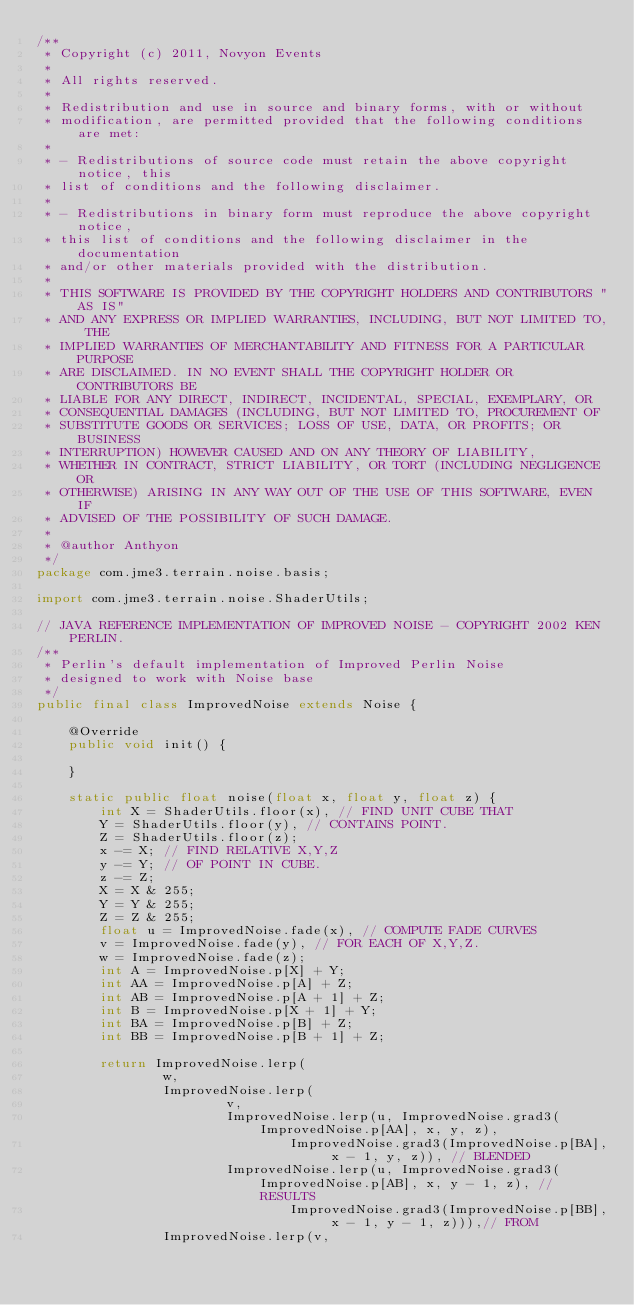Convert code to text. <code><loc_0><loc_0><loc_500><loc_500><_Java_>/**
 * Copyright (c) 2011, Novyon Events
 * 
 * All rights reserved.
 * 
 * Redistribution and use in source and binary forms, with or without
 * modification, are permitted provided that the following conditions are met:
 * 
 * - Redistributions of source code must retain the above copyright notice, this
 * list of conditions and the following disclaimer.
 * 
 * - Redistributions in binary form must reproduce the above copyright notice,
 * this list of conditions and the following disclaimer in the documentation
 * and/or other materials provided with the distribution.
 * 
 * THIS SOFTWARE IS PROVIDED BY THE COPYRIGHT HOLDERS AND CONTRIBUTORS "AS IS"
 * AND ANY EXPRESS OR IMPLIED WARRANTIES, INCLUDING, BUT NOT LIMITED TO, THE
 * IMPLIED WARRANTIES OF MERCHANTABILITY AND FITNESS FOR A PARTICULAR PURPOSE
 * ARE DISCLAIMED. IN NO EVENT SHALL THE COPYRIGHT HOLDER OR CONTRIBUTORS BE
 * LIABLE FOR ANY DIRECT, INDIRECT, INCIDENTAL, SPECIAL, EXEMPLARY, OR
 * CONSEQUENTIAL DAMAGES (INCLUDING, BUT NOT LIMITED TO, PROCUREMENT OF
 * SUBSTITUTE GOODS OR SERVICES; LOSS OF USE, DATA, OR PROFITS; OR BUSINESS
 * INTERRUPTION) HOWEVER CAUSED AND ON ANY THEORY OF LIABILITY,
 * WHETHER IN CONTRACT, STRICT LIABILITY, OR TORT (INCLUDING NEGLIGENCE OR
 * OTHERWISE) ARISING IN ANY WAY OUT OF THE USE OF THIS SOFTWARE, EVEN IF
 * ADVISED OF THE POSSIBILITY OF SUCH DAMAGE.
 * 
 * @author Anthyon
 */
package com.jme3.terrain.noise.basis;

import com.jme3.terrain.noise.ShaderUtils;

// JAVA REFERENCE IMPLEMENTATION OF IMPROVED NOISE - COPYRIGHT 2002 KEN PERLIN.
/**
 * Perlin's default implementation of Improved Perlin Noise
 * designed to work with Noise base
 */
public final class ImprovedNoise extends Noise {

    @Override
    public void init() {

    }

    static public float noise(float x, float y, float z) {
        int X = ShaderUtils.floor(x), // FIND UNIT CUBE THAT
        Y = ShaderUtils.floor(y), // CONTAINS POINT.
        Z = ShaderUtils.floor(z);
        x -= X; // FIND RELATIVE X,Y,Z
        y -= Y; // OF POINT IN CUBE.
        z -= Z;
        X = X & 255;
        Y = Y & 255;
        Z = Z & 255;
        float u = ImprovedNoise.fade(x), // COMPUTE FADE CURVES
        v = ImprovedNoise.fade(y), // FOR EACH OF X,Y,Z.
        w = ImprovedNoise.fade(z);
        int A = ImprovedNoise.p[X] + Y;
        int AA = ImprovedNoise.p[A] + Z;
        int AB = ImprovedNoise.p[A + 1] + Z;
        int B = ImprovedNoise.p[X + 1] + Y;
        int BA = ImprovedNoise.p[B] + Z;
        int BB = ImprovedNoise.p[B + 1] + Z;

        return ImprovedNoise.lerp(
                w,
                ImprovedNoise.lerp(
                        v,
                        ImprovedNoise.lerp(u, ImprovedNoise.grad3(ImprovedNoise.p[AA], x, y, z),
                                ImprovedNoise.grad3(ImprovedNoise.p[BA], x - 1, y, z)), // BLENDED
                        ImprovedNoise.lerp(u, ImprovedNoise.grad3(ImprovedNoise.p[AB], x, y - 1, z), // RESULTS
                                ImprovedNoise.grad3(ImprovedNoise.p[BB], x - 1, y - 1, z))),// FROM
                ImprovedNoise.lerp(v,</code> 